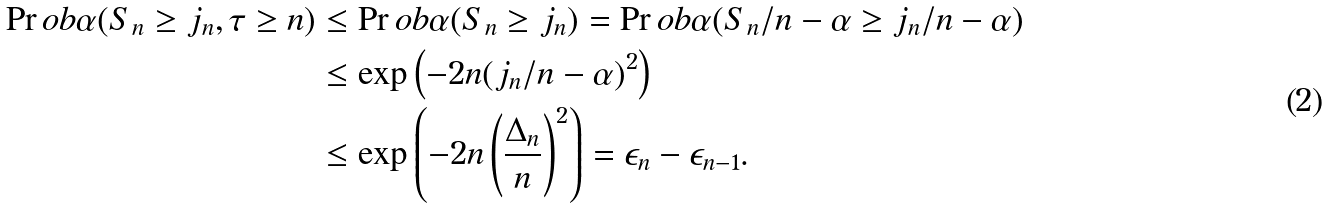Convert formula to latex. <formula><loc_0><loc_0><loc_500><loc_500>\Pr o b { \alpha } ( S _ { n } \geq j _ { n } , \tau \geq n ) & \leq \Pr o b { \alpha } ( S _ { n } \geq j _ { n } ) = \Pr o b { \alpha } ( S _ { n } / n - \alpha \geq j _ { n } / n - \alpha ) \\ & \leq \exp \left ( - 2 n ( j _ { n } / n - \alpha ) ^ { 2 } \right ) \\ & \leq \exp \left ( - 2 n \left ( \frac { \Delta _ { n } } { n } \right ) ^ { 2 } \right ) = \epsilon _ { n } - \epsilon _ { n - 1 } .</formula> 